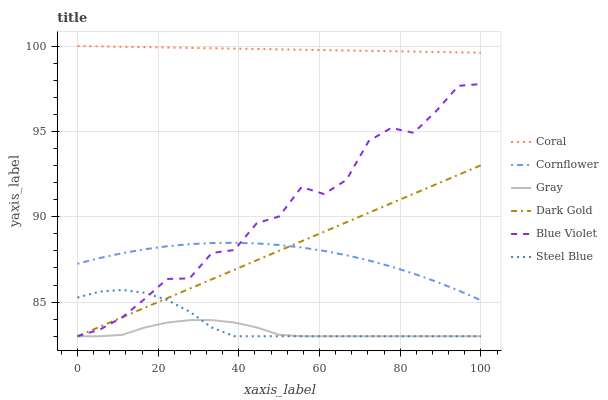Does Gray have the minimum area under the curve?
Answer yes or no. Yes. Does Coral have the maximum area under the curve?
Answer yes or no. Yes. Does Dark Gold have the minimum area under the curve?
Answer yes or no. No. Does Dark Gold have the maximum area under the curve?
Answer yes or no. No. Is Dark Gold the smoothest?
Answer yes or no. Yes. Is Blue Violet the roughest?
Answer yes or no. Yes. Is Coral the smoothest?
Answer yes or no. No. Is Coral the roughest?
Answer yes or no. No. Does Coral have the lowest value?
Answer yes or no. No. Does Coral have the highest value?
Answer yes or no. Yes. Does Dark Gold have the highest value?
Answer yes or no. No. Is Gray less than Coral?
Answer yes or no. Yes. Is Cornflower greater than Steel Blue?
Answer yes or no. Yes. Does Dark Gold intersect Gray?
Answer yes or no. Yes. Is Dark Gold less than Gray?
Answer yes or no. No. Is Dark Gold greater than Gray?
Answer yes or no. No. Does Gray intersect Coral?
Answer yes or no. No. 